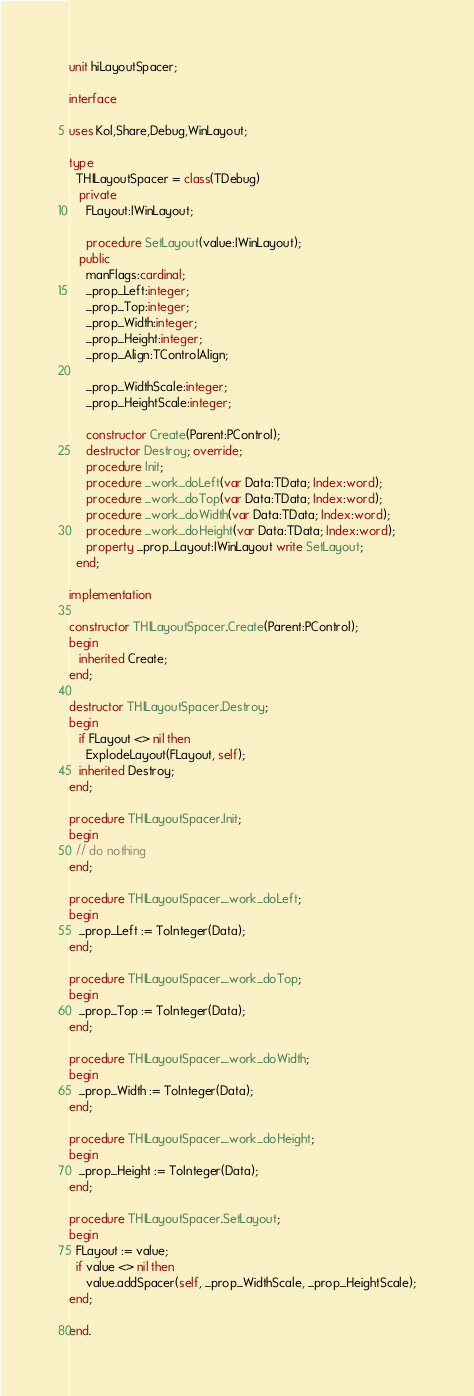Convert code to text. <code><loc_0><loc_0><loc_500><loc_500><_Pascal_>unit hiLayoutSpacer;

interface

uses Kol,Share,Debug,WinLayout;

type
  THILayoutSpacer = class(TDebug)
   private
     FLayout:IWinLayout;
     
     procedure SetLayout(value:IWinLayout);
   public 
     manFlags:cardinal;
     _prop_Left:integer;
     _prop_Top:integer;
     _prop_Width:integer;
     _prop_Height:integer;
     _prop_Align:TControlAlign;

     _prop_WidthScale:integer;
     _prop_HeightScale:integer;

     constructor Create(Parent:PControl);
     destructor Destroy; override; 
     procedure Init;
     procedure _work_doLeft(var Data:TData; Index:word);
     procedure _work_doTop(var Data:TData; Index:word);
     procedure _work_doWidth(var Data:TData; Index:word);
     procedure _work_doHeight(var Data:TData; Index:word);
     property _prop_Layout:IWinLayout write SetLayout;
  end;

implementation

constructor THILayoutSpacer.Create(Parent:PControl);
begin
   inherited Create;
end;

destructor THILayoutSpacer.Destroy;
begin   
   if FLayout <> nil then
     ExplodeLayout(FLayout, self);
   inherited Destroy;
end;

procedure THILayoutSpacer.Init;
begin
  // do nothing
end;

procedure THILayoutSpacer._work_doLeft;
begin
   _prop_Left := ToInteger(Data);
end;

procedure THILayoutSpacer._work_doTop;
begin
   _prop_Top := ToInteger(Data);
end;

procedure THILayoutSpacer._work_doWidth;
begin
   _prop_Width := ToInteger(Data);
end;

procedure THILayoutSpacer._work_doHeight;
begin
   _prop_Height := ToInteger(Data);
end;

procedure THILayoutSpacer.SetLayout;
begin
  FLayout := value;
  if value <> nil then
     value.addSpacer(self, _prop_WidthScale, _prop_HeightScale);
end;

end.
</code> 